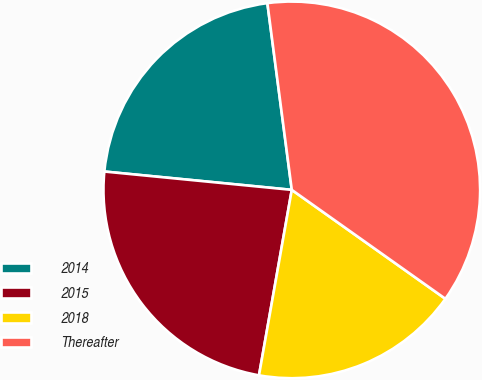Convert chart to OTSL. <chart><loc_0><loc_0><loc_500><loc_500><pie_chart><fcel>2014<fcel>2015<fcel>2018<fcel>Thereafter<nl><fcel>21.38%<fcel>23.77%<fcel>17.97%<fcel>36.89%<nl></chart> 